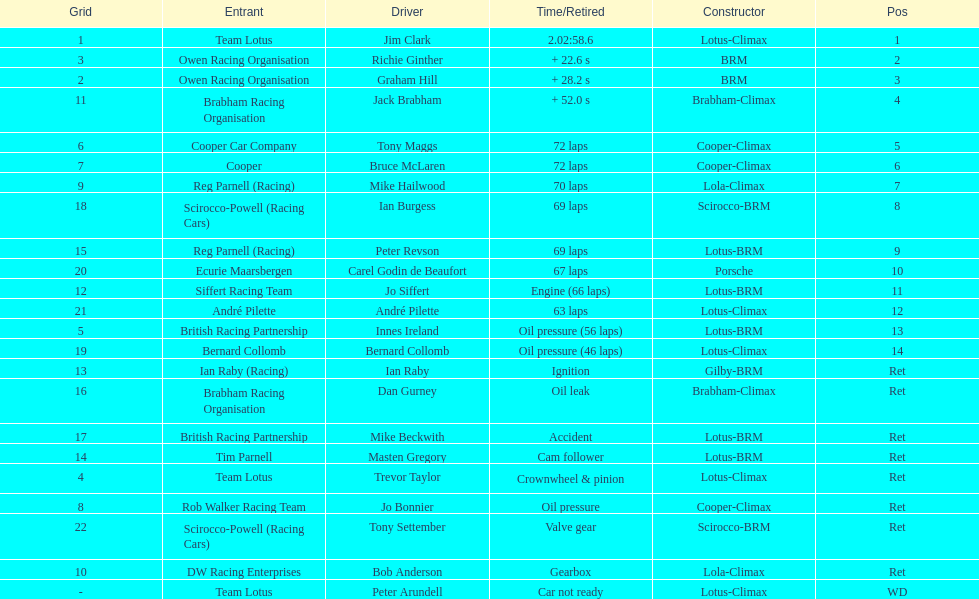What is the number of americans in the top 5? 1. 